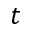Convert formula to latex. <formula><loc_0><loc_0><loc_500><loc_500>t</formula> 